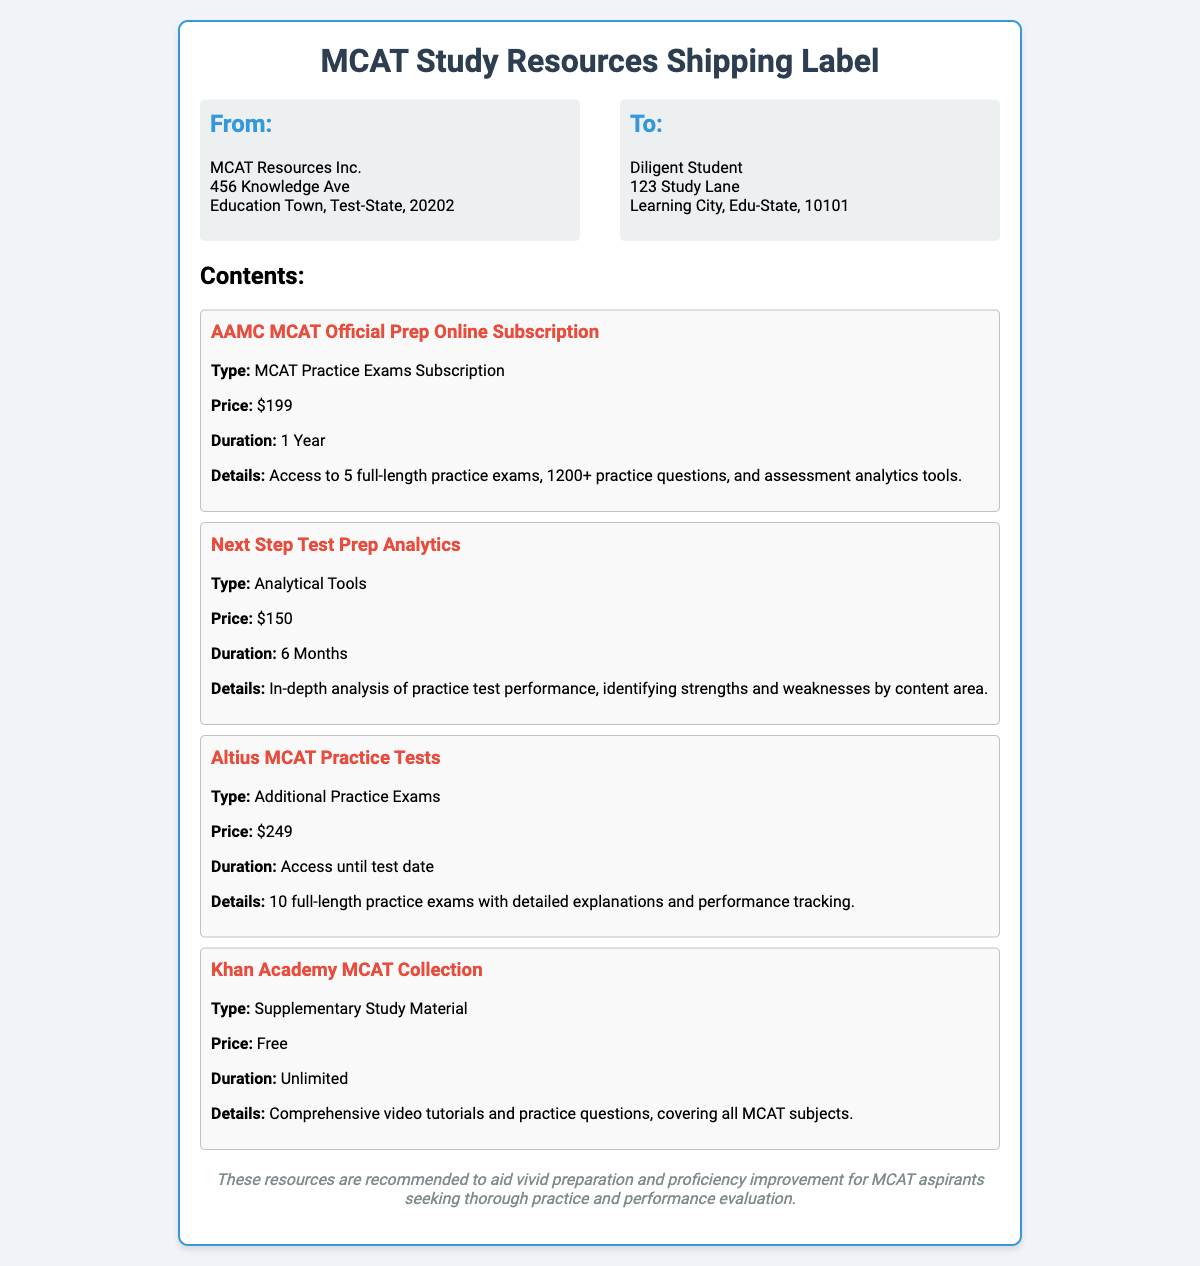What is the company name that ships the resources? The document displays the name of the shipping company in the "From" section, which is MCAT Resources Inc.
Answer: MCAT Resources Inc How much does the AAMC MCAT Official Prep Online Subscription cost? The price for this subscription is stated under its details, which is $199.
Answer: $199 What is the duration of the Next Step Test Prep Analytics? The document specifies the duration of this subscription, which is 6 months.
Answer: 6 Months How many practice exams are included in the AAMC MCAT Official Prep Online Subscription? The details mention access to 5 full-length practice exams.
Answer: 5 What type of resource is the Khan Academy MCAT Collection? The document categorizes this resource under "Supplementary Study Material."
Answer: Supplementary Study Material What is the total price of all the listed resources? To find this, we should add the individual prices from the document: $199 + $150 + $249 + $0.
Answer: $598 Which resource provides performance tracking? The details of the Altius MCAT Practice Tests indicate it includes detailed explanations and performance tracking.
Answer: Altius MCAT Practice Tests What is the address of the sender? The sender's address can be found in the "From" section, which includes "456 Knowledge Ave, Education Town, Test-State, 20202."
Answer: 456 Knowledge Ave, Education Town, Test-State, 20202 What kind of analysis does the Next Step Test Prep Analytics offer? The document states that it offers an in-depth analysis of practice test performance.
Answer: In-depth analysis of practice test performance 